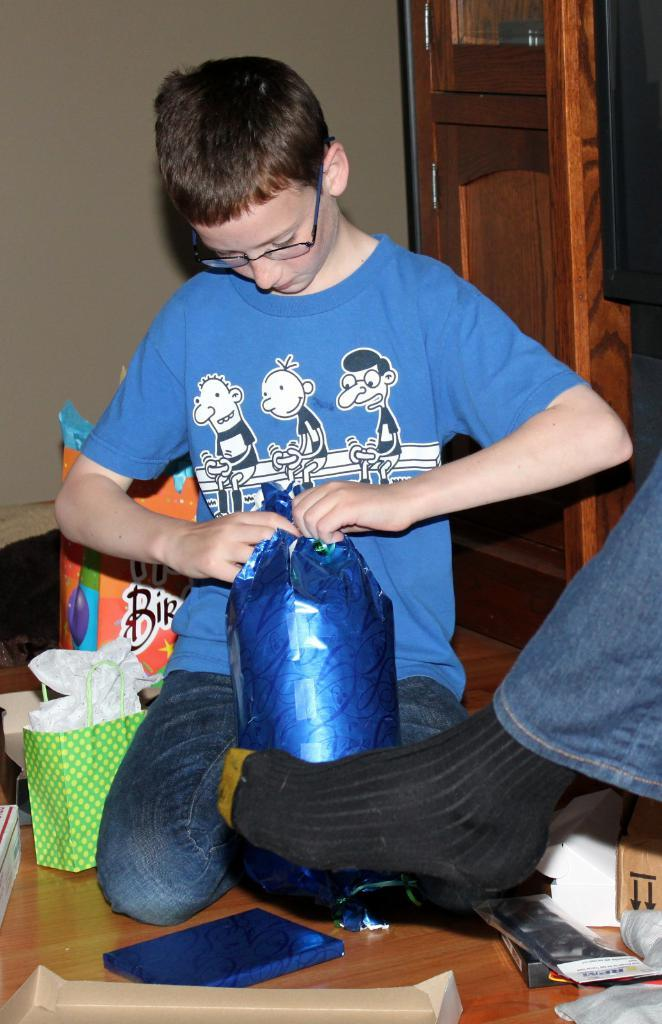Who is present in the image? There is a boy in the image. What is the boy wearing? The boy is wearing spectacles. What can be seen on the floor in the image? There are bags and gifts on the floor in the image. What is visible in the background of the image? There is a wall, cupboards, and a person's leg visible in the background of the image. What type of plough is being used in the image? There is no plough present in the image. What event is taking place in the image? The image does not depict a specific event; it shows a boy with bags and gifts on the floor. 